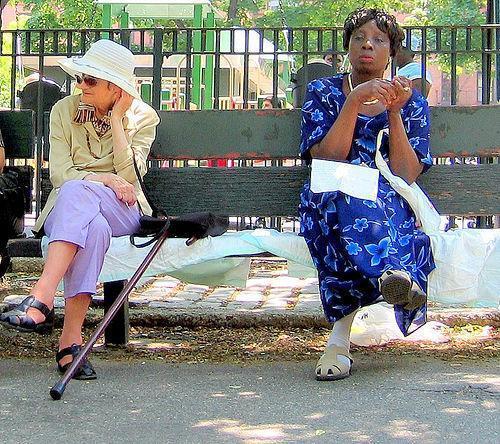How many people are there?
Give a very brief answer. 2. 